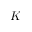<formula> <loc_0><loc_0><loc_500><loc_500>K</formula> 